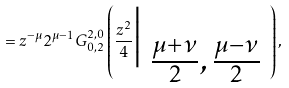Convert formula to latex. <formula><loc_0><loc_0><loc_500><loc_500>= z ^ { - \mu } 2 ^ { \mu - 1 } G _ { { 0 } , { 2 } } ^ { { 2 } , { 0 } } \left ( \frac { z ^ { 2 } } { 4 } \Big { | } \begin{array} { l l l } \\ \frac { \mu + \nu } { 2 } , \frac { \mu - \nu } { 2 } \end{array} \right ) ,</formula> 